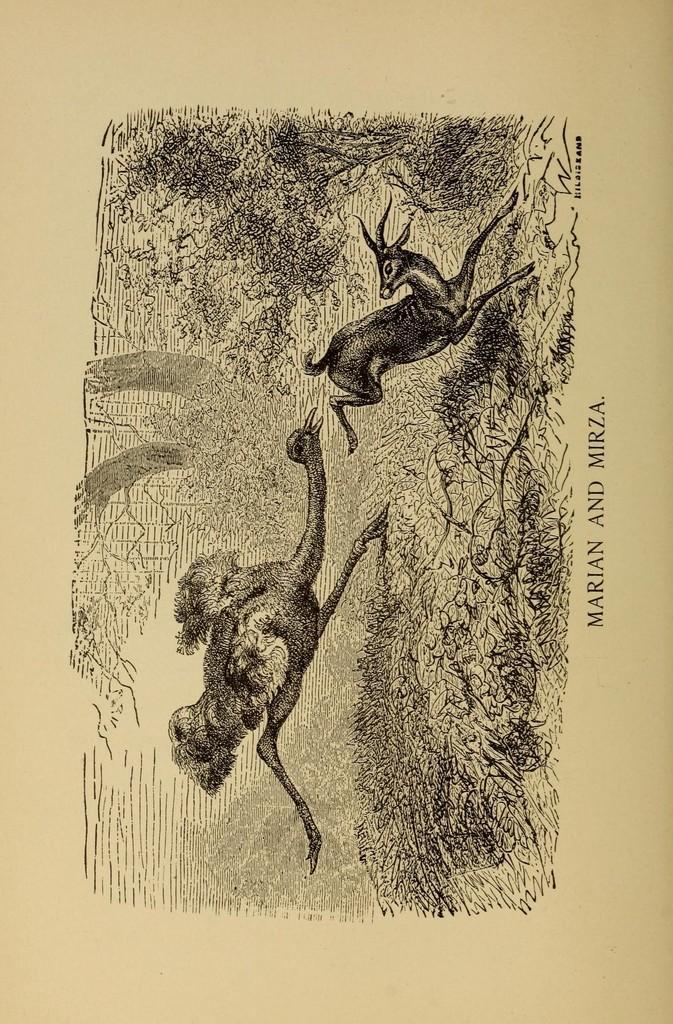Could you give a brief overview of what you see in this image? In this image we can see drawing of an ostrich and an animal. Also there is a text on the image. 